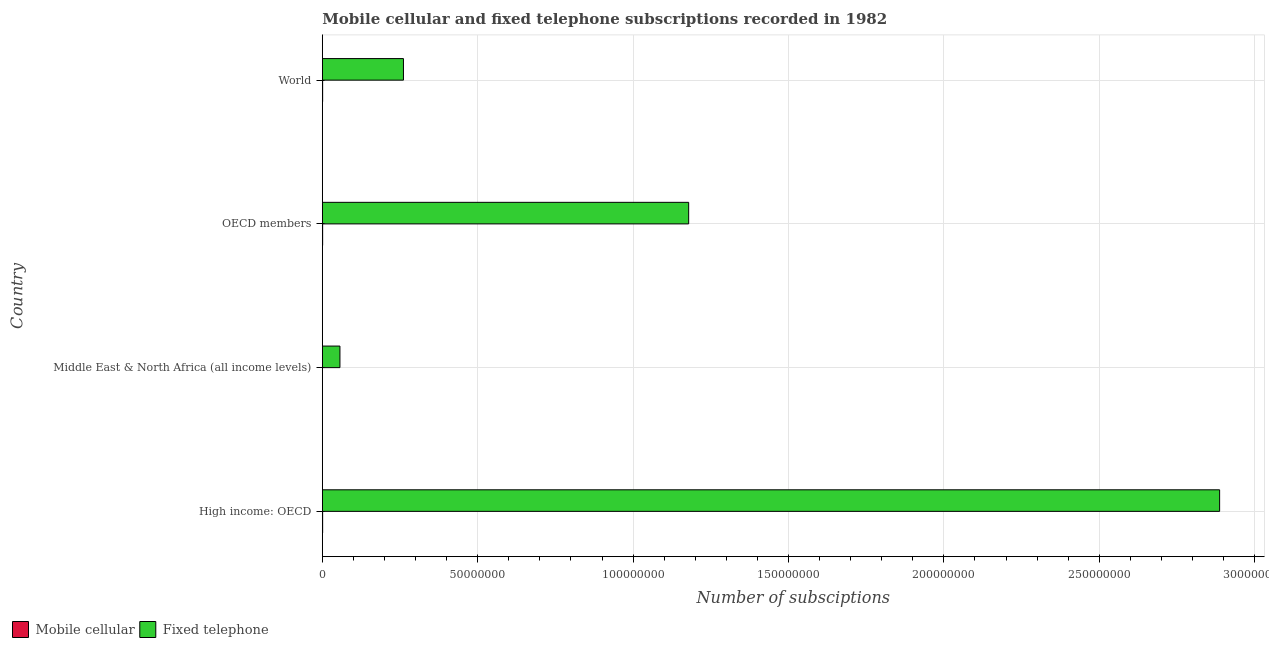How many different coloured bars are there?
Your response must be concise. 2. Are the number of bars per tick equal to the number of legend labels?
Your answer should be compact. Yes. How many bars are there on the 3rd tick from the top?
Your response must be concise. 2. How many bars are there on the 4th tick from the bottom?
Your response must be concise. 2. What is the number of fixed telephone subscriptions in Middle East & North Africa (all income levels)?
Offer a terse response. 5.67e+06. Across all countries, what is the maximum number of mobile cellular subscriptions?
Your answer should be very brief. 1.02e+05. Across all countries, what is the minimum number of mobile cellular subscriptions?
Provide a succinct answer. 2330. In which country was the number of fixed telephone subscriptions maximum?
Your answer should be very brief. High income: OECD. In which country was the number of fixed telephone subscriptions minimum?
Your answer should be very brief. Middle East & North Africa (all income levels). What is the total number of fixed telephone subscriptions in the graph?
Provide a short and direct response. 4.38e+08. What is the difference between the number of mobile cellular subscriptions in Middle East & North Africa (all income levels) and that in OECD members?
Give a very brief answer. -9.68e+04. What is the difference between the number of mobile cellular subscriptions in OECD members and the number of fixed telephone subscriptions in Middle East & North Africa (all income levels)?
Make the answer very short. -5.57e+06. What is the average number of mobile cellular subscriptions per country?
Ensure brevity in your answer.  7.55e+04. What is the difference between the number of fixed telephone subscriptions and number of mobile cellular subscriptions in Middle East & North Africa (all income levels)?
Your response must be concise. 5.67e+06. In how many countries, is the number of mobile cellular subscriptions greater than 50000000 ?
Provide a succinct answer. 0. What is the ratio of the number of fixed telephone subscriptions in Middle East & North Africa (all income levels) to that in OECD members?
Your answer should be very brief. 0.05. Is the difference between the number of mobile cellular subscriptions in OECD members and World greater than the difference between the number of fixed telephone subscriptions in OECD members and World?
Your answer should be very brief. No. What is the difference between the highest and the second highest number of mobile cellular subscriptions?
Your answer should be compact. 2330. What is the difference between the highest and the lowest number of fixed telephone subscriptions?
Your answer should be compact. 2.83e+08. In how many countries, is the number of fixed telephone subscriptions greater than the average number of fixed telephone subscriptions taken over all countries?
Provide a succinct answer. 2. What does the 1st bar from the top in Middle East & North Africa (all income levels) represents?
Offer a very short reply. Fixed telephone. What does the 1st bar from the bottom in World represents?
Provide a short and direct response. Mobile cellular. Are all the bars in the graph horizontal?
Provide a short and direct response. Yes. Does the graph contain grids?
Your response must be concise. Yes. Where does the legend appear in the graph?
Your answer should be compact. Bottom left. How many legend labels are there?
Offer a terse response. 2. How are the legend labels stacked?
Provide a succinct answer. Horizontal. What is the title of the graph?
Offer a terse response. Mobile cellular and fixed telephone subscriptions recorded in 1982. What is the label or title of the X-axis?
Provide a succinct answer. Number of subsciptions. What is the label or title of the Y-axis?
Provide a short and direct response. Country. What is the Number of subsciptions of Mobile cellular in High income: OECD?
Keep it short and to the point. 9.92e+04. What is the Number of subsciptions of Fixed telephone in High income: OECD?
Make the answer very short. 2.89e+08. What is the Number of subsciptions of Mobile cellular in Middle East & North Africa (all income levels)?
Provide a short and direct response. 2330. What is the Number of subsciptions of Fixed telephone in Middle East & North Africa (all income levels)?
Your answer should be very brief. 5.67e+06. What is the Number of subsciptions of Mobile cellular in OECD members?
Your answer should be very brief. 9.92e+04. What is the Number of subsciptions of Fixed telephone in OECD members?
Give a very brief answer. 1.18e+08. What is the Number of subsciptions in Mobile cellular in World?
Your answer should be compact. 1.02e+05. What is the Number of subsciptions in Fixed telephone in World?
Make the answer very short. 2.61e+07. Across all countries, what is the maximum Number of subsciptions of Mobile cellular?
Make the answer very short. 1.02e+05. Across all countries, what is the maximum Number of subsciptions of Fixed telephone?
Offer a very short reply. 2.89e+08. Across all countries, what is the minimum Number of subsciptions of Mobile cellular?
Your response must be concise. 2330. Across all countries, what is the minimum Number of subsciptions of Fixed telephone?
Ensure brevity in your answer.  5.67e+06. What is the total Number of subsciptions in Mobile cellular in the graph?
Ensure brevity in your answer.  3.02e+05. What is the total Number of subsciptions of Fixed telephone in the graph?
Provide a short and direct response. 4.38e+08. What is the difference between the Number of subsciptions of Mobile cellular in High income: OECD and that in Middle East & North Africa (all income levels)?
Ensure brevity in your answer.  9.68e+04. What is the difference between the Number of subsciptions in Fixed telephone in High income: OECD and that in Middle East & North Africa (all income levels)?
Your answer should be very brief. 2.83e+08. What is the difference between the Number of subsciptions in Fixed telephone in High income: OECD and that in OECD members?
Keep it short and to the point. 1.71e+08. What is the difference between the Number of subsciptions of Mobile cellular in High income: OECD and that in World?
Provide a succinct answer. -2330. What is the difference between the Number of subsciptions in Fixed telephone in High income: OECD and that in World?
Provide a succinct answer. 2.63e+08. What is the difference between the Number of subsciptions in Mobile cellular in Middle East & North Africa (all income levels) and that in OECD members?
Your response must be concise. -9.68e+04. What is the difference between the Number of subsciptions in Fixed telephone in Middle East & North Africa (all income levels) and that in OECD members?
Keep it short and to the point. -1.12e+08. What is the difference between the Number of subsciptions in Mobile cellular in Middle East & North Africa (all income levels) and that in World?
Give a very brief answer. -9.92e+04. What is the difference between the Number of subsciptions in Fixed telephone in Middle East & North Africa (all income levels) and that in World?
Make the answer very short. -2.04e+07. What is the difference between the Number of subsciptions in Mobile cellular in OECD members and that in World?
Your answer should be compact. -2330. What is the difference between the Number of subsciptions of Fixed telephone in OECD members and that in World?
Make the answer very short. 9.18e+07. What is the difference between the Number of subsciptions of Mobile cellular in High income: OECD and the Number of subsciptions of Fixed telephone in Middle East & North Africa (all income levels)?
Your answer should be compact. -5.57e+06. What is the difference between the Number of subsciptions of Mobile cellular in High income: OECD and the Number of subsciptions of Fixed telephone in OECD members?
Offer a very short reply. -1.18e+08. What is the difference between the Number of subsciptions of Mobile cellular in High income: OECD and the Number of subsciptions of Fixed telephone in World?
Provide a short and direct response. -2.60e+07. What is the difference between the Number of subsciptions of Mobile cellular in Middle East & North Africa (all income levels) and the Number of subsciptions of Fixed telephone in OECD members?
Your answer should be very brief. -1.18e+08. What is the difference between the Number of subsciptions of Mobile cellular in Middle East & North Africa (all income levels) and the Number of subsciptions of Fixed telephone in World?
Your response must be concise. -2.61e+07. What is the difference between the Number of subsciptions in Mobile cellular in OECD members and the Number of subsciptions in Fixed telephone in World?
Provide a short and direct response. -2.60e+07. What is the average Number of subsciptions of Mobile cellular per country?
Your response must be concise. 7.55e+04. What is the average Number of subsciptions in Fixed telephone per country?
Provide a short and direct response. 1.10e+08. What is the difference between the Number of subsciptions in Mobile cellular and Number of subsciptions in Fixed telephone in High income: OECD?
Your response must be concise. -2.89e+08. What is the difference between the Number of subsciptions of Mobile cellular and Number of subsciptions of Fixed telephone in Middle East & North Africa (all income levels)?
Provide a succinct answer. -5.67e+06. What is the difference between the Number of subsciptions in Mobile cellular and Number of subsciptions in Fixed telephone in OECD members?
Provide a short and direct response. -1.18e+08. What is the difference between the Number of subsciptions in Mobile cellular and Number of subsciptions in Fixed telephone in World?
Give a very brief answer. -2.60e+07. What is the ratio of the Number of subsciptions of Mobile cellular in High income: OECD to that in Middle East & North Africa (all income levels)?
Your answer should be compact. 42.57. What is the ratio of the Number of subsciptions in Fixed telephone in High income: OECD to that in Middle East & North Africa (all income levels)?
Provide a succinct answer. 50.94. What is the ratio of the Number of subsciptions of Mobile cellular in High income: OECD to that in OECD members?
Your answer should be very brief. 1. What is the ratio of the Number of subsciptions in Fixed telephone in High income: OECD to that in OECD members?
Provide a short and direct response. 2.45. What is the ratio of the Number of subsciptions of Mobile cellular in High income: OECD to that in World?
Provide a short and direct response. 0.98. What is the ratio of the Number of subsciptions of Fixed telephone in High income: OECD to that in World?
Provide a succinct answer. 11.06. What is the ratio of the Number of subsciptions in Mobile cellular in Middle East & North Africa (all income levels) to that in OECD members?
Ensure brevity in your answer.  0.02. What is the ratio of the Number of subsciptions in Fixed telephone in Middle East & North Africa (all income levels) to that in OECD members?
Ensure brevity in your answer.  0.05. What is the ratio of the Number of subsciptions of Mobile cellular in Middle East & North Africa (all income levels) to that in World?
Your answer should be very brief. 0.02. What is the ratio of the Number of subsciptions of Fixed telephone in Middle East & North Africa (all income levels) to that in World?
Ensure brevity in your answer.  0.22. What is the ratio of the Number of subsciptions in Fixed telephone in OECD members to that in World?
Your answer should be compact. 4.52. What is the difference between the highest and the second highest Number of subsciptions in Mobile cellular?
Your response must be concise. 2330. What is the difference between the highest and the second highest Number of subsciptions of Fixed telephone?
Provide a succinct answer. 1.71e+08. What is the difference between the highest and the lowest Number of subsciptions of Mobile cellular?
Offer a terse response. 9.92e+04. What is the difference between the highest and the lowest Number of subsciptions of Fixed telephone?
Your answer should be very brief. 2.83e+08. 